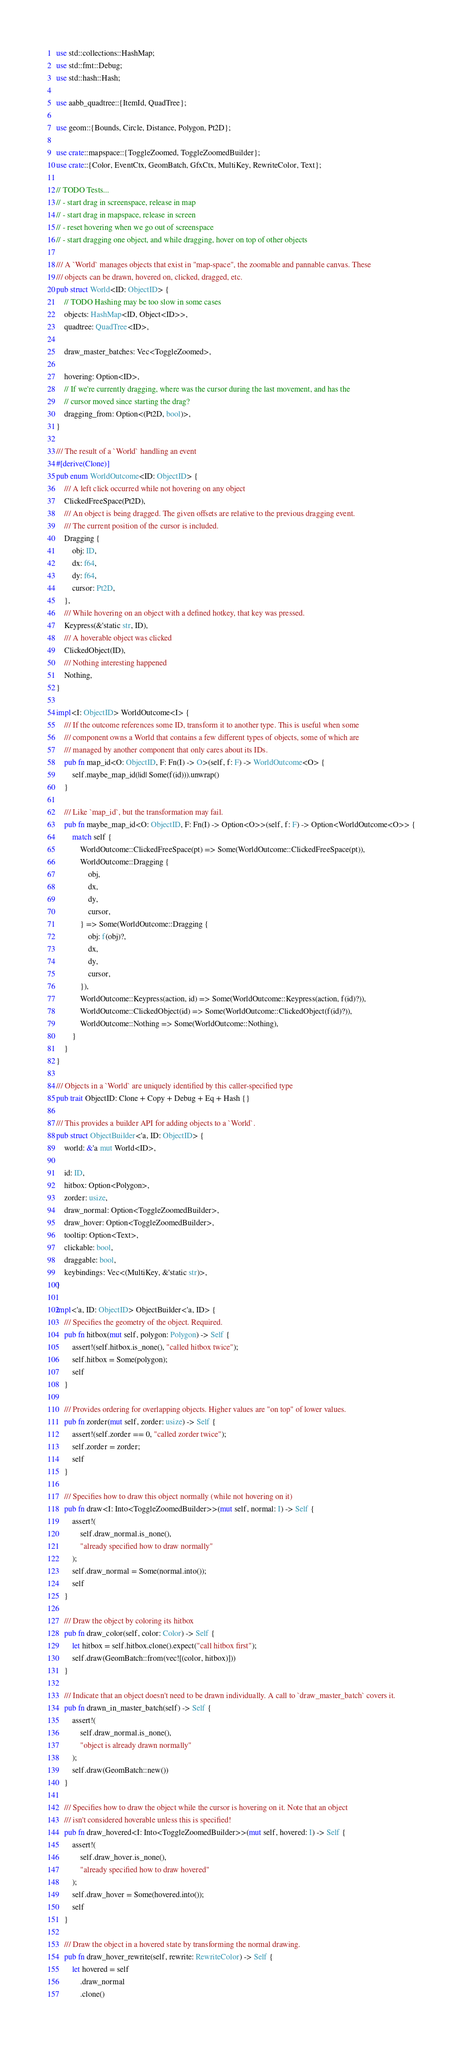Convert code to text. <code><loc_0><loc_0><loc_500><loc_500><_Rust_>use std::collections::HashMap;
use std::fmt::Debug;
use std::hash::Hash;

use aabb_quadtree::{ItemId, QuadTree};

use geom::{Bounds, Circle, Distance, Polygon, Pt2D};

use crate::mapspace::{ToggleZoomed, ToggleZoomedBuilder};
use crate::{Color, EventCtx, GeomBatch, GfxCtx, MultiKey, RewriteColor, Text};

// TODO Tests...
// - start drag in screenspace, release in map
// - start drag in mapspace, release in screen
// - reset hovering when we go out of screenspace
// - start dragging one object, and while dragging, hover on top of other objects

/// A `World` manages objects that exist in "map-space", the zoomable and pannable canvas. These
/// objects can be drawn, hovered on, clicked, dragged, etc.
pub struct World<ID: ObjectID> {
    // TODO Hashing may be too slow in some cases
    objects: HashMap<ID, Object<ID>>,
    quadtree: QuadTree<ID>,

    draw_master_batches: Vec<ToggleZoomed>,

    hovering: Option<ID>,
    // If we're currently dragging, where was the cursor during the last movement, and has the
    // cursor moved since starting the drag?
    dragging_from: Option<(Pt2D, bool)>,
}

/// The result of a `World` handling an event
#[derive(Clone)]
pub enum WorldOutcome<ID: ObjectID> {
    /// A left click occurred while not hovering on any object
    ClickedFreeSpace(Pt2D),
    /// An object is being dragged. The given offsets are relative to the previous dragging event.
    /// The current position of the cursor is included.
    Dragging {
        obj: ID,
        dx: f64,
        dy: f64,
        cursor: Pt2D,
    },
    /// While hovering on an object with a defined hotkey, that key was pressed.
    Keypress(&'static str, ID),
    /// A hoverable object was clicked
    ClickedObject(ID),
    /// Nothing interesting happened
    Nothing,
}

impl<I: ObjectID> WorldOutcome<I> {
    /// If the outcome references some ID, transform it to another type. This is useful when some
    /// component owns a World that contains a few different types of objects, some of which are
    /// managed by another component that only cares about its IDs.
    pub fn map_id<O: ObjectID, F: Fn(I) -> O>(self, f: F) -> WorldOutcome<O> {
        self.maybe_map_id(|id| Some(f(id))).unwrap()
    }

    /// Like `map_id`, but the transformation may fail.
    pub fn maybe_map_id<O: ObjectID, F: Fn(I) -> Option<O>>(self, f: F) -> Option<WorldOutcome<O>> {
        match self {
            WorldOutcome::ClickedFreeSpace(pt) => Some(WorldOutcome::ClickedFreeSpace(pt)),
            WorldOutcome::Dragging {
                obj,
                dx,
                dy,
                cursor,
            } => Some(WorldOutcome::Dragging {
                obj: f(obj)?,
                dx,
                dy,
                cursor,
            }),
            WorldOutcome::Keypress(action, id) => Some(WorldOutcome::Keypress(action, f(id)?)),
            WorldOutcome::ClickedObject(id) => Some(WorldOutcome::ClickedObject(f(id)?)),
            WorldOutcome::Nothing => Some(WorldOutcome::Nothing),
        }
    }
}

/// Objects in a `World` are uniquely identified by this caller-specified type
pub trait ObjectID: Clone + Copy + Debug + Eq + Hash {}

/// This provides a builder API for adding objects to a `World`.
pub struct ObjectBuilder<'a, ID: ObjectID> {
    world: &'a mut World<ID>,

    id: ID,
    hitbox: Option<Polygon>,
    zorder: usize,
    draw_normal: Option<ToggleZoomedBuilder>,
    draw_hover: Option<ToggleZoomedBuilder>,
    tooltip: Option<Text>,
    clickable: bool,
    draggable: bool,
    keybindings: Vec<(MultiKey, &'static str)>,
}

impl<'a, ID: ObjectID> ObjectBuilder<'a, ID> {
    /// Specifies the geometry of the object. Required.
    pub fn hitbox(mut self, polygon: Polygon) -> Self {
        assert!(self.hitbox.is_none(), "called hitbox twice");
        self.hitbox = Some(polygon);
        self
    }

    /// Provides ordering for overlapping objects. Higher values are "on top" of lower values.
    pub fn zorder(mut self, zorder: usize) -> Self {
        assert!(self.zorder == 0, "called zorder twice");
        self.zorder = zorder;
        self
    }

    /// Specifies how to draw this object normally (while not hovering on it)
    pub fn draw<I: Into<ToggleZoomedBuilder>>(mut self, normal: I) -> Self {
        assert!(
            self.draw_normal.is_none(),
            "already specified how to draw normally"
        );
        self.draw_normal = Some(normal.into());
        self
    }

    /// Draw the object by coloring its hitbox
    pub fn draw_color(self, color: Color) -> Self {
        let hitbox = self.hitbox.clone().expect("call hitbox first");
        self.draw(GeomBatch::from(vec![(color, hitbox)]))
    }

    /// Indicate that an object doesn't need to be drawn individually. A call to `draw_master_batch` covers it.
    pub fn drawn_in_master_batch(self) -> Self {
        assert!(
            self.draw_normal.is_none(),
            "object is already drawn normally"
        );
        self.draw(GeomBatch::new())
    }

    /// Specifies how to draw the object while the cursor is hovering on it. Note that an object
    /// isn't considered hoverable unless this is specified!
    pub fn draw_hovered<I: Into<ToggleZoomedBuilder>>(mut self, hovered: I) -> Self {
        assert!(
            self.draw_hover.is_none(),
            "already specified how to draw hovered"
        );
        self.draw_hover = Some(hovered.into());
        self
    }

    /// Draw the object in a hovered state by transforming the normal drawing.
    pub fn draw_hover_rewrite(self, rewrite: RewriteColor) -> Self {
        let hovered = self
            .draw_normal
            .clone()</code> 